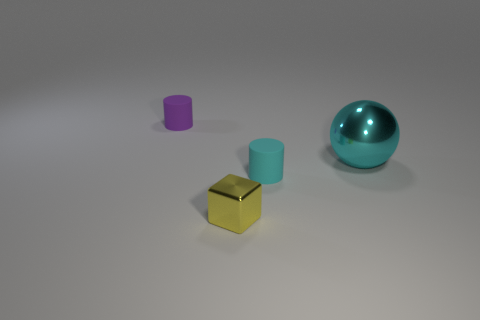There is a tiny thing that is the same color as the metallic sphere; what is its shape?
Your answer should be very brief. Cylinder. Are there any other matte objects that have the same shape as the purple matte thing?
Provide a succinct answer. Yes. The purple object that is the same size as the yellow cube is what shape?
Provide a short and direct response. Cylinder. There is a big metal thing; does it have the same color as the small cylinder that is in front of the large cyan sphere?
Your answer should be compact. Yes. What number of objects are to the right of the tiny matte thing to the left of the small shiny cube?
Your answer should be very brief. 3. There is a thing that is behind the small cyan matte cylinder and in front of the purple cylinder; how big is it?
Your answer should be compact. Large. Is there a cylinder that has the same size as the purple matte object?
Your answer should be compact. Yes. Are there more cylinders behind the large cyan shiny ball than small yellow blocks behind the small purple rubber thing?
Ensure brevity in your answer.  Yes. Is the material of the purple cylinder the same as the small cylinder in front of the large ball?
Your response must be concise. Yes. How many cubes are to the right of the cylinder in front of the cyan thing behind the small cyan rubber object?
Your answer should be very brief. 0. 